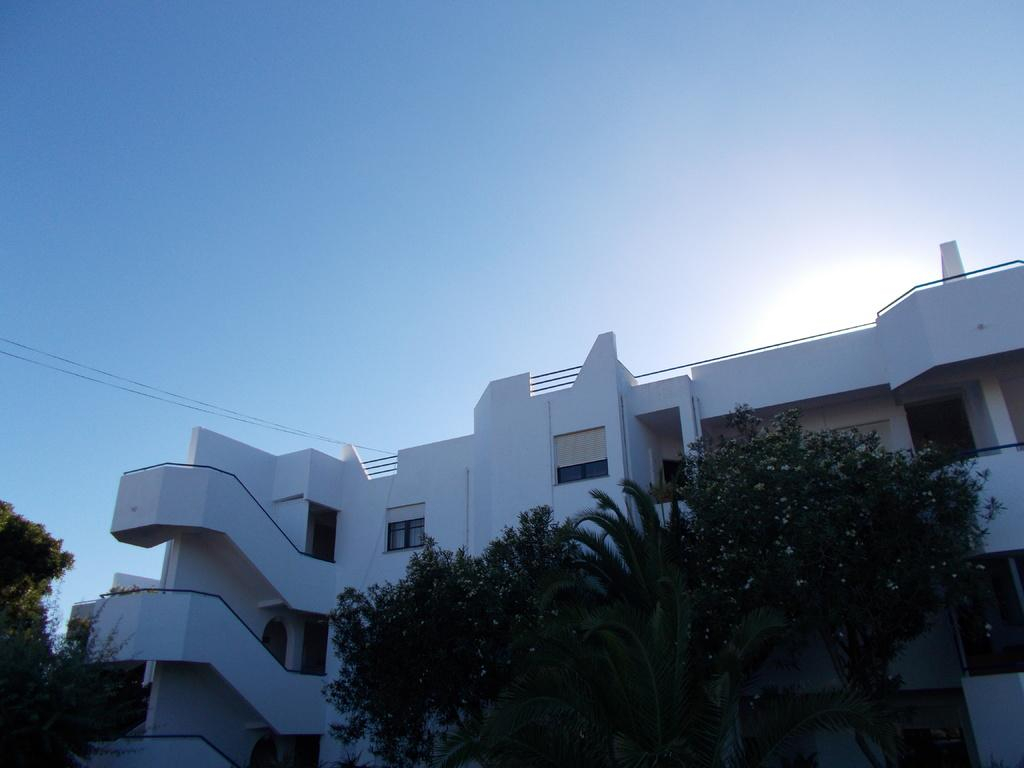What type of vegetation is at the bottom of the image? There are trees at the bottom of the image. What structure is located behind the trees? There is a building behind the trees. What is visible at the top of the image? The sky is visible at the top of the image. Can you tell me how many goldfish are swimming in the channel in the image? There is no channel or goldfish present in the image. What is the level of disgust expressed by the trees in the image? Trees do not express emotions like disgust, and there is no indication of any emotion in the image. 